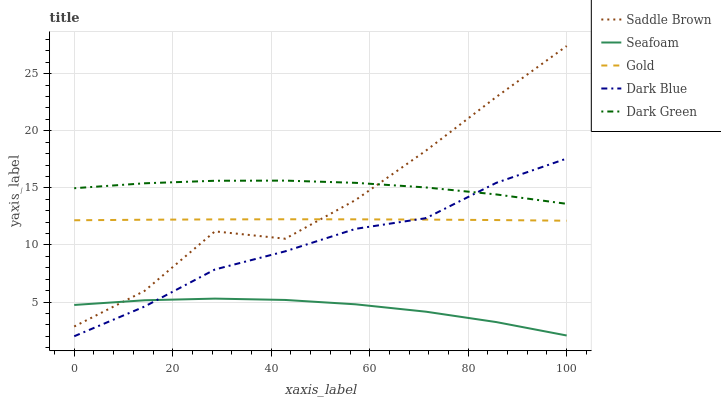Does Seafoam have the minimum area under the curve?
Answer yes or no. Yes. Does Dark Green have the maximum area under the curve?
Answer yes or no. Yes. Does Saddle Brown have the minimum area under the curve?
Answer yes or no. No. Does Saddle Brown have the maximum area under the curve?
Answer yes or no. No. Is Gold the smoothest?
Answer yes or no. Yes. Is Saddle Brown the roughest?
Answer yes or no. Yes. Is Dark Green the smoothest?
Answer yes or no. No. Is Dark Green the roughest?
Answer yes or no. No. Does Dark Blue have the lowest value?
Answer yes or no. Yes. Does Saddle Brown have the lowest value?
Answer yes or no. No. Does Saddle Brown have the highest value?
Answer yes or no. Yes. Does Dark Green have the highest value?
Answer yes or no. No. Is Seafoam less than Dark Green?
Answer yes or no. Yes. Is Saddle Brown greater than Dark Blue?
Answer yes or no. Yes. Does Dark Green intersect Saddle Brown?
Answer yes or no. Yes. Is Dark Green less than Saddle Brown?
Answer yes or no. No. Is Dark Green greater than Saddle Brown?
Answer yes or no. No. Does Seafoam intersect Dark Green?
Answer yes or no. No. 